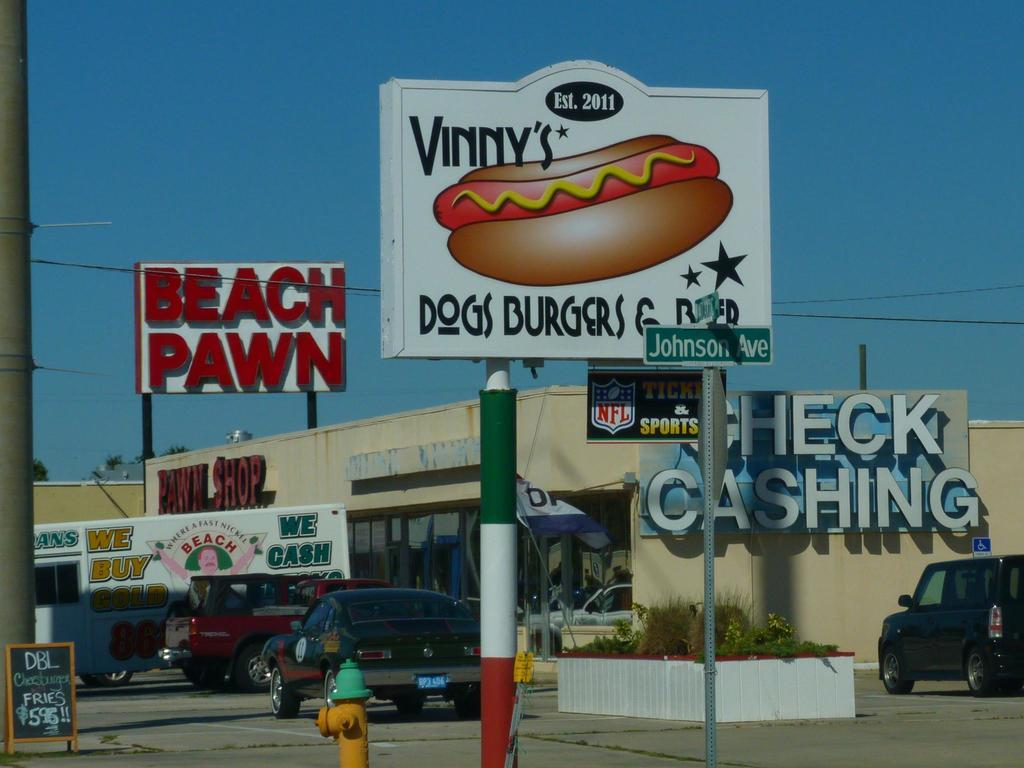<image>
Provide a brief description of the given image. Large sign for a restuarant that says Vinny's on it. 